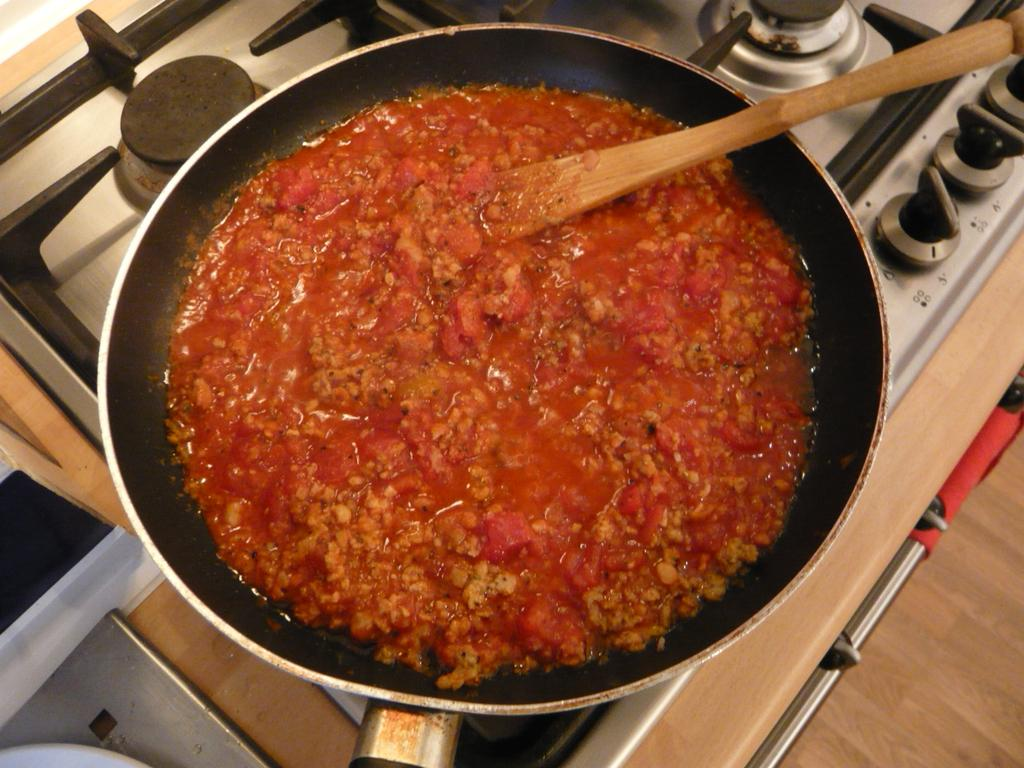What is the main object in the image? There is a frying pan in the image. Where is the frying pan located? The frying pan is placed on a stove. What is inside the frying pan? The frying pan contains a food item. What utensil can be seen in the image? There is a wooden serving spoon in the image. How many mice are running on the roof in the image? There are no mice or roof present in the image. What time is indicated by the clocks in the image? There are no clocks present in the image. 